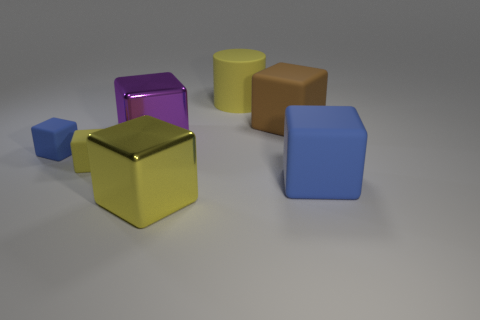How many large objects are either yellow things or yellow metallic blocks?
Offer a terse response. 2. What material is the large object that is the same color as the cylinder?
Offer a terse response. Metal. Is the number of blue metal objects less than the number of brown rubber blocks?
Ensure brevity in your answer.  Yes. There is a blue rubber object on the left side of the big purple object; is it the same size as the blue block that is right of the brown rubber thing?
Offer a terse response. No. How many yellow things are big metallic things or rubber cylinders?
Ensure brevity in your answer.  2. The matte cube that is the same color as the large cylinder is what size?
Offer a very short reply. Small. Is the number of small green rubber cubes greater than the number of big blue blocks?
Provide a succinct answer. No. How many objects are big purple objects or rubber objects that are behind the large brown matte cube?
Offer a very short reply. 2. How many other objects are there of the same shape as the large blue thing?
Provide a short and direct response. 5. Is the number of yellow things to the left of the big yellow cylinder less than the number of small blue things that are in front of the tiny blue thing?
Provide a succinct answer. No. 